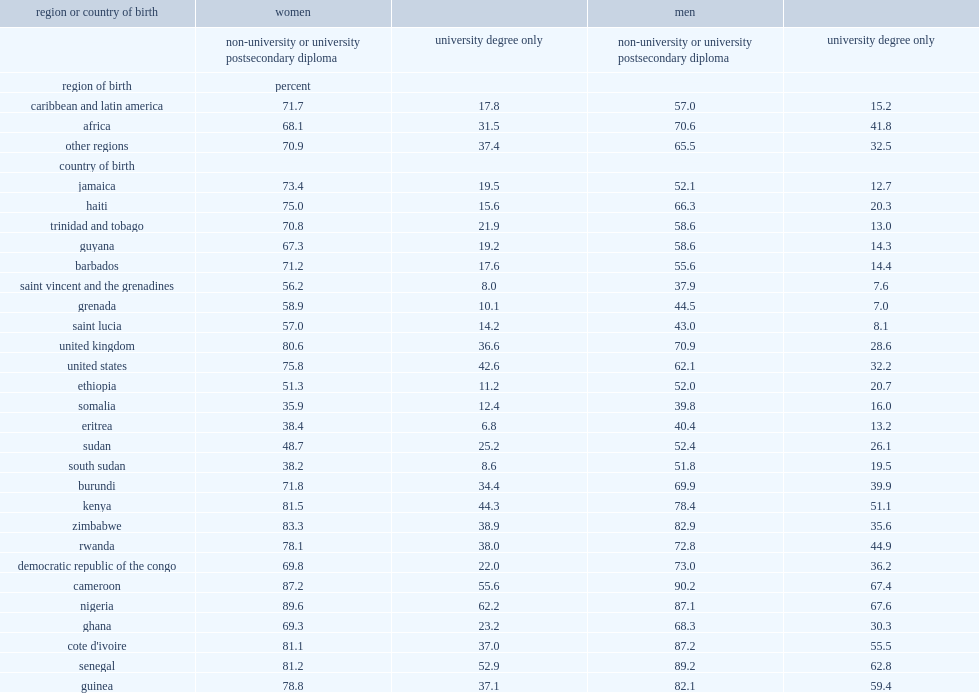Which region of birth has fewer proportion of black male immigrants with a postsecondary diploma or a university diploma? black male immigrants from africa or from caribbean and latin america? Caribbean and latin america. Which region of birth has higher proportion of black female immigrants with a postsecondary diploma or a university diploma? black female immigrants from africa or from caribbean and latin america? Caribbean and latin america. 